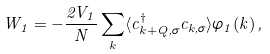Convert formula to latex. <formula><loc_0><loc_0><loc_500><loc_500>W _ { 1 } = - \frac { 2 V _ { 1 } } { N } \sum _ { k } \langle c _ { k + Q , \sigma } ^ { \dagger } c _ { k , \sigma } \rangle \varphi _ { 1 } ( k ) \, ,</formula> 